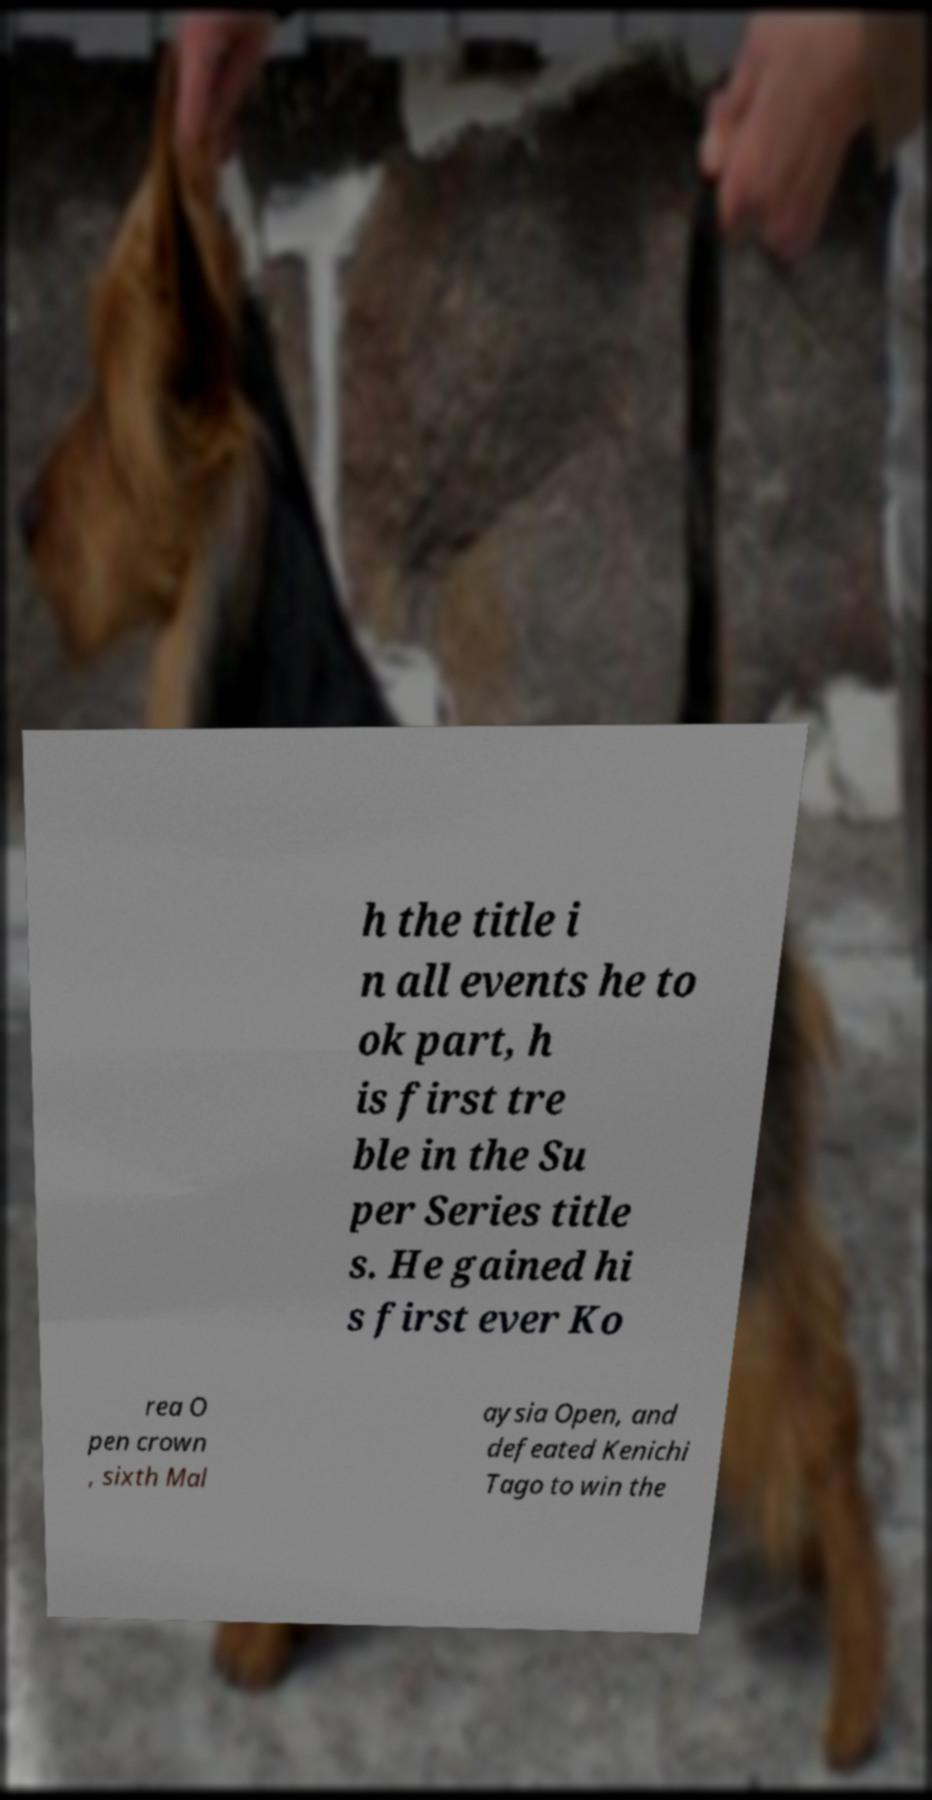Could you extract and type out the text from this image? h the title i n all events he to ok part, h is first tre ble in the Su per Series title s. He gained hi s first ever Ko rea O pen crown , sixth Mal aysia Open, and defeated Kenichi Tago to win the 